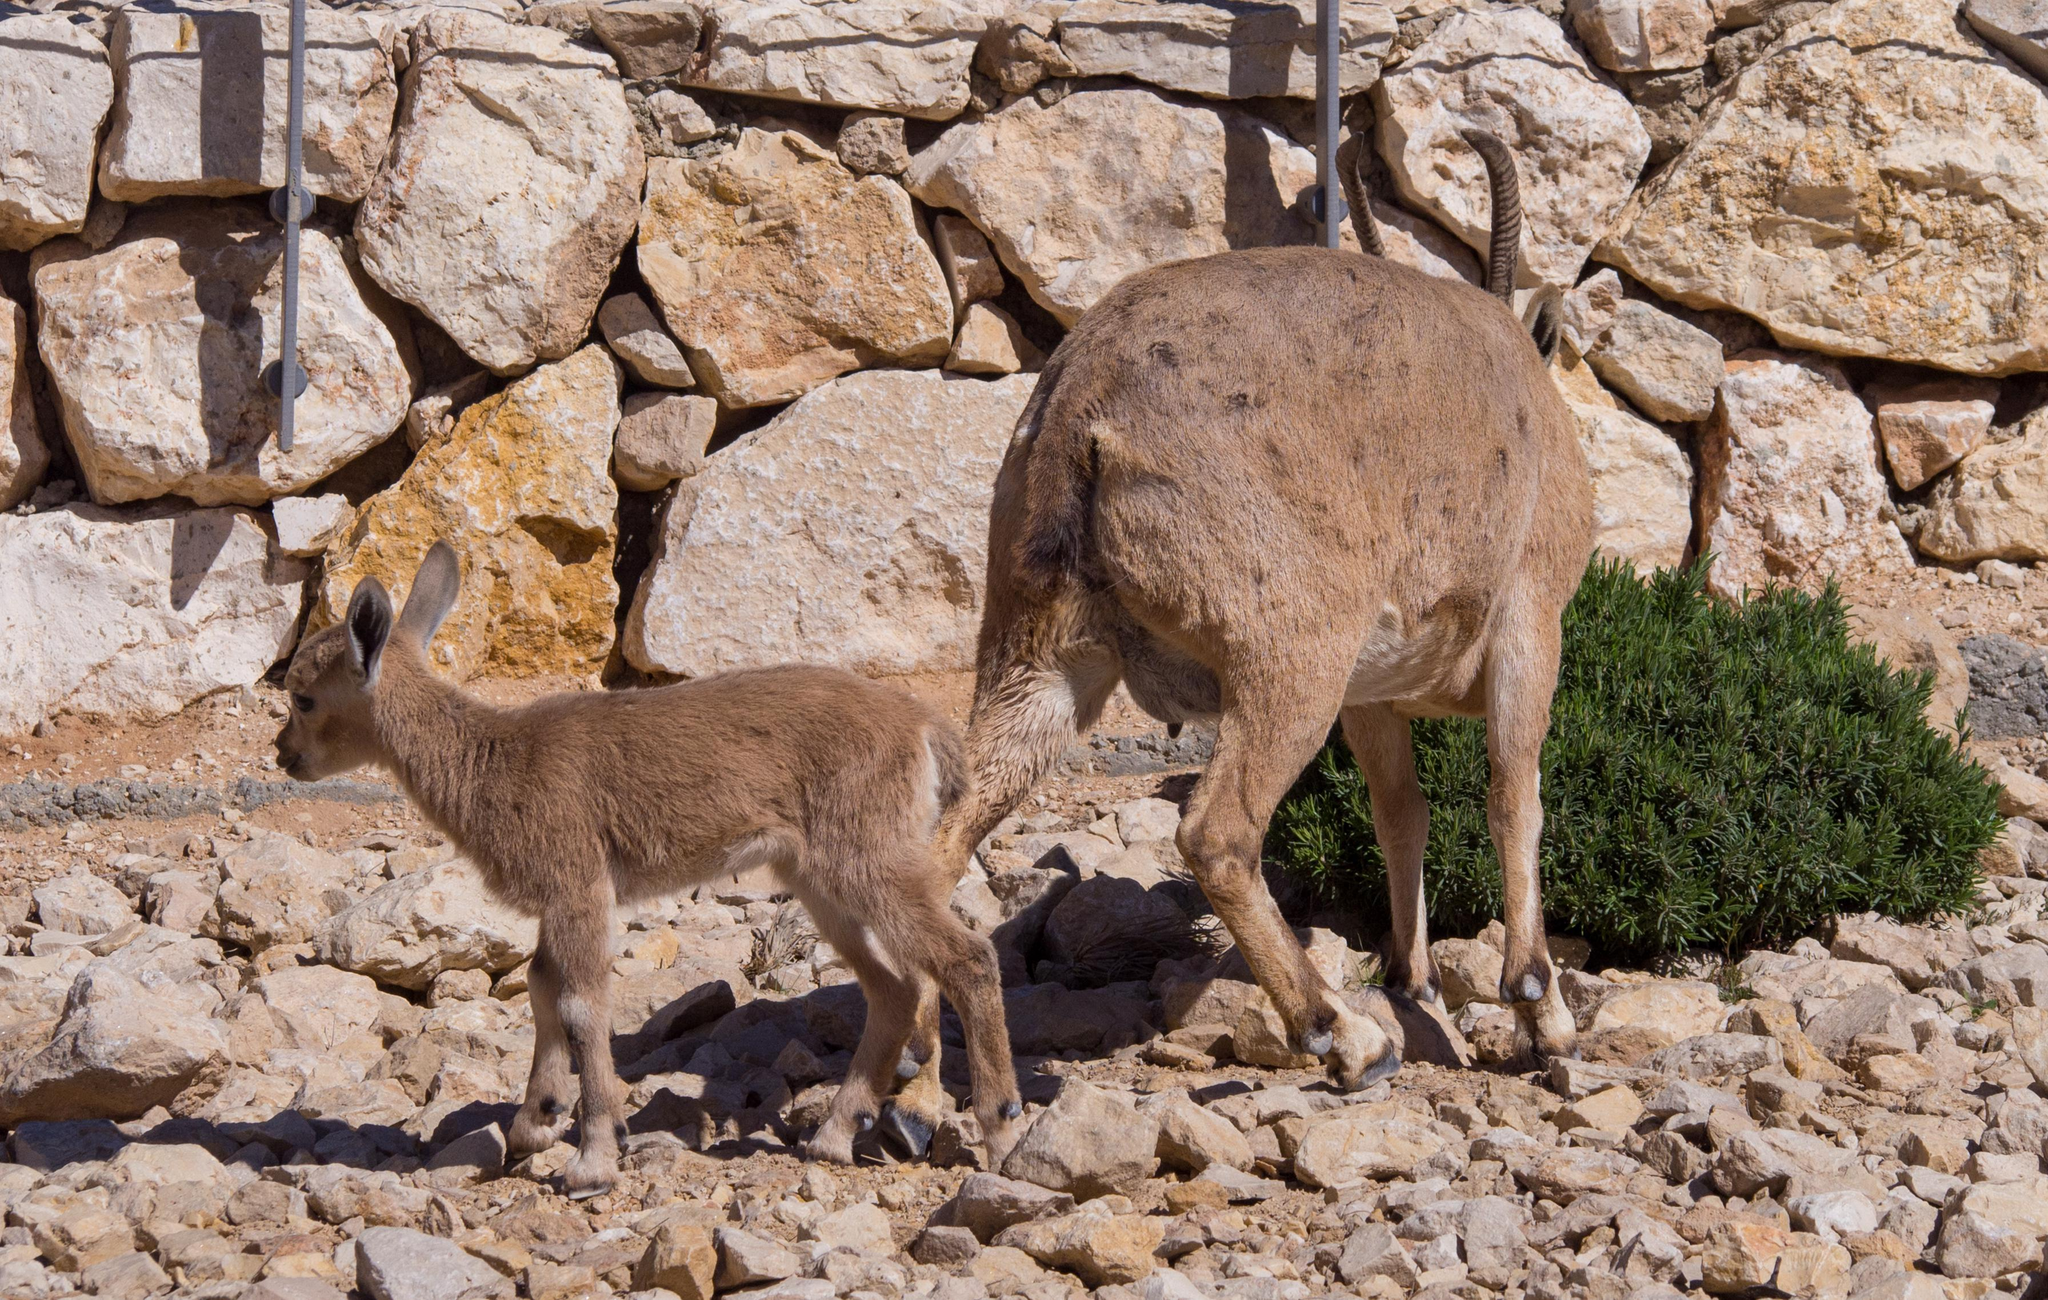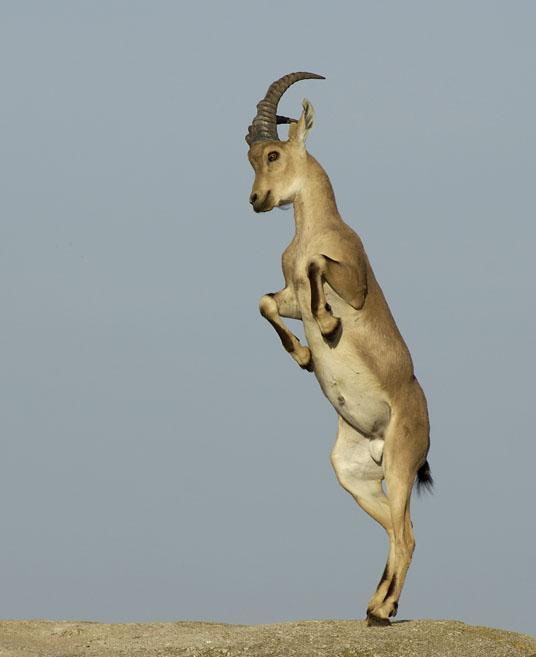The first image is the image on the left, the second image is the image on the right. Assess this claim about the two images: "The left and right image contains a total of four goats.". Correct or not? Answer yes or no. No. The first image is the image on the left, the second image is the image on the right. Analyze the images presented: Is the assertion "The left image contains a bigger horned animal and at least one smaller animal without a set of prominent horns." valid? Answer yes or no. Yes. 